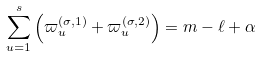Convert formula to latex. <formula><loc_0><loc_0><loc_500><loc_500>\sum _ { u = 1 } ^ { s } \left ( \varpi ^ { ( \sigma , 1 ) } _ { u } + \varpi ^ { ( \sigma , 2 ) } _ { u } \right ) = m - \ell + \alpha</formula> 